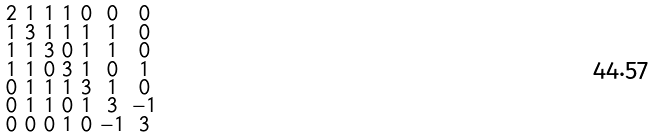<formula> <loc_0><loc_0><loc_500><loc_500>\begin{smallmatrix} 2 & 1 & 1 & 1 & 0 & 0 & 0 \\ 1 & 3 & 1 & 1 & 1 & 1 & 0 \\ 1 & 1 & 3 & 0 & 1 & 1 & 0 \\ 1 & 1 & 0 & 3 & 1 & 0 & 1 \\ 0 & 1 & 1 & 1 & 3 & 1 & 0 \\ 0 & 1 & 1 & 0 & 1 & 3 & - 1 \\ 0 & 0 & 0 & 1 & 0 & - 1 & 3 \end{smallmatrix}</formula> 